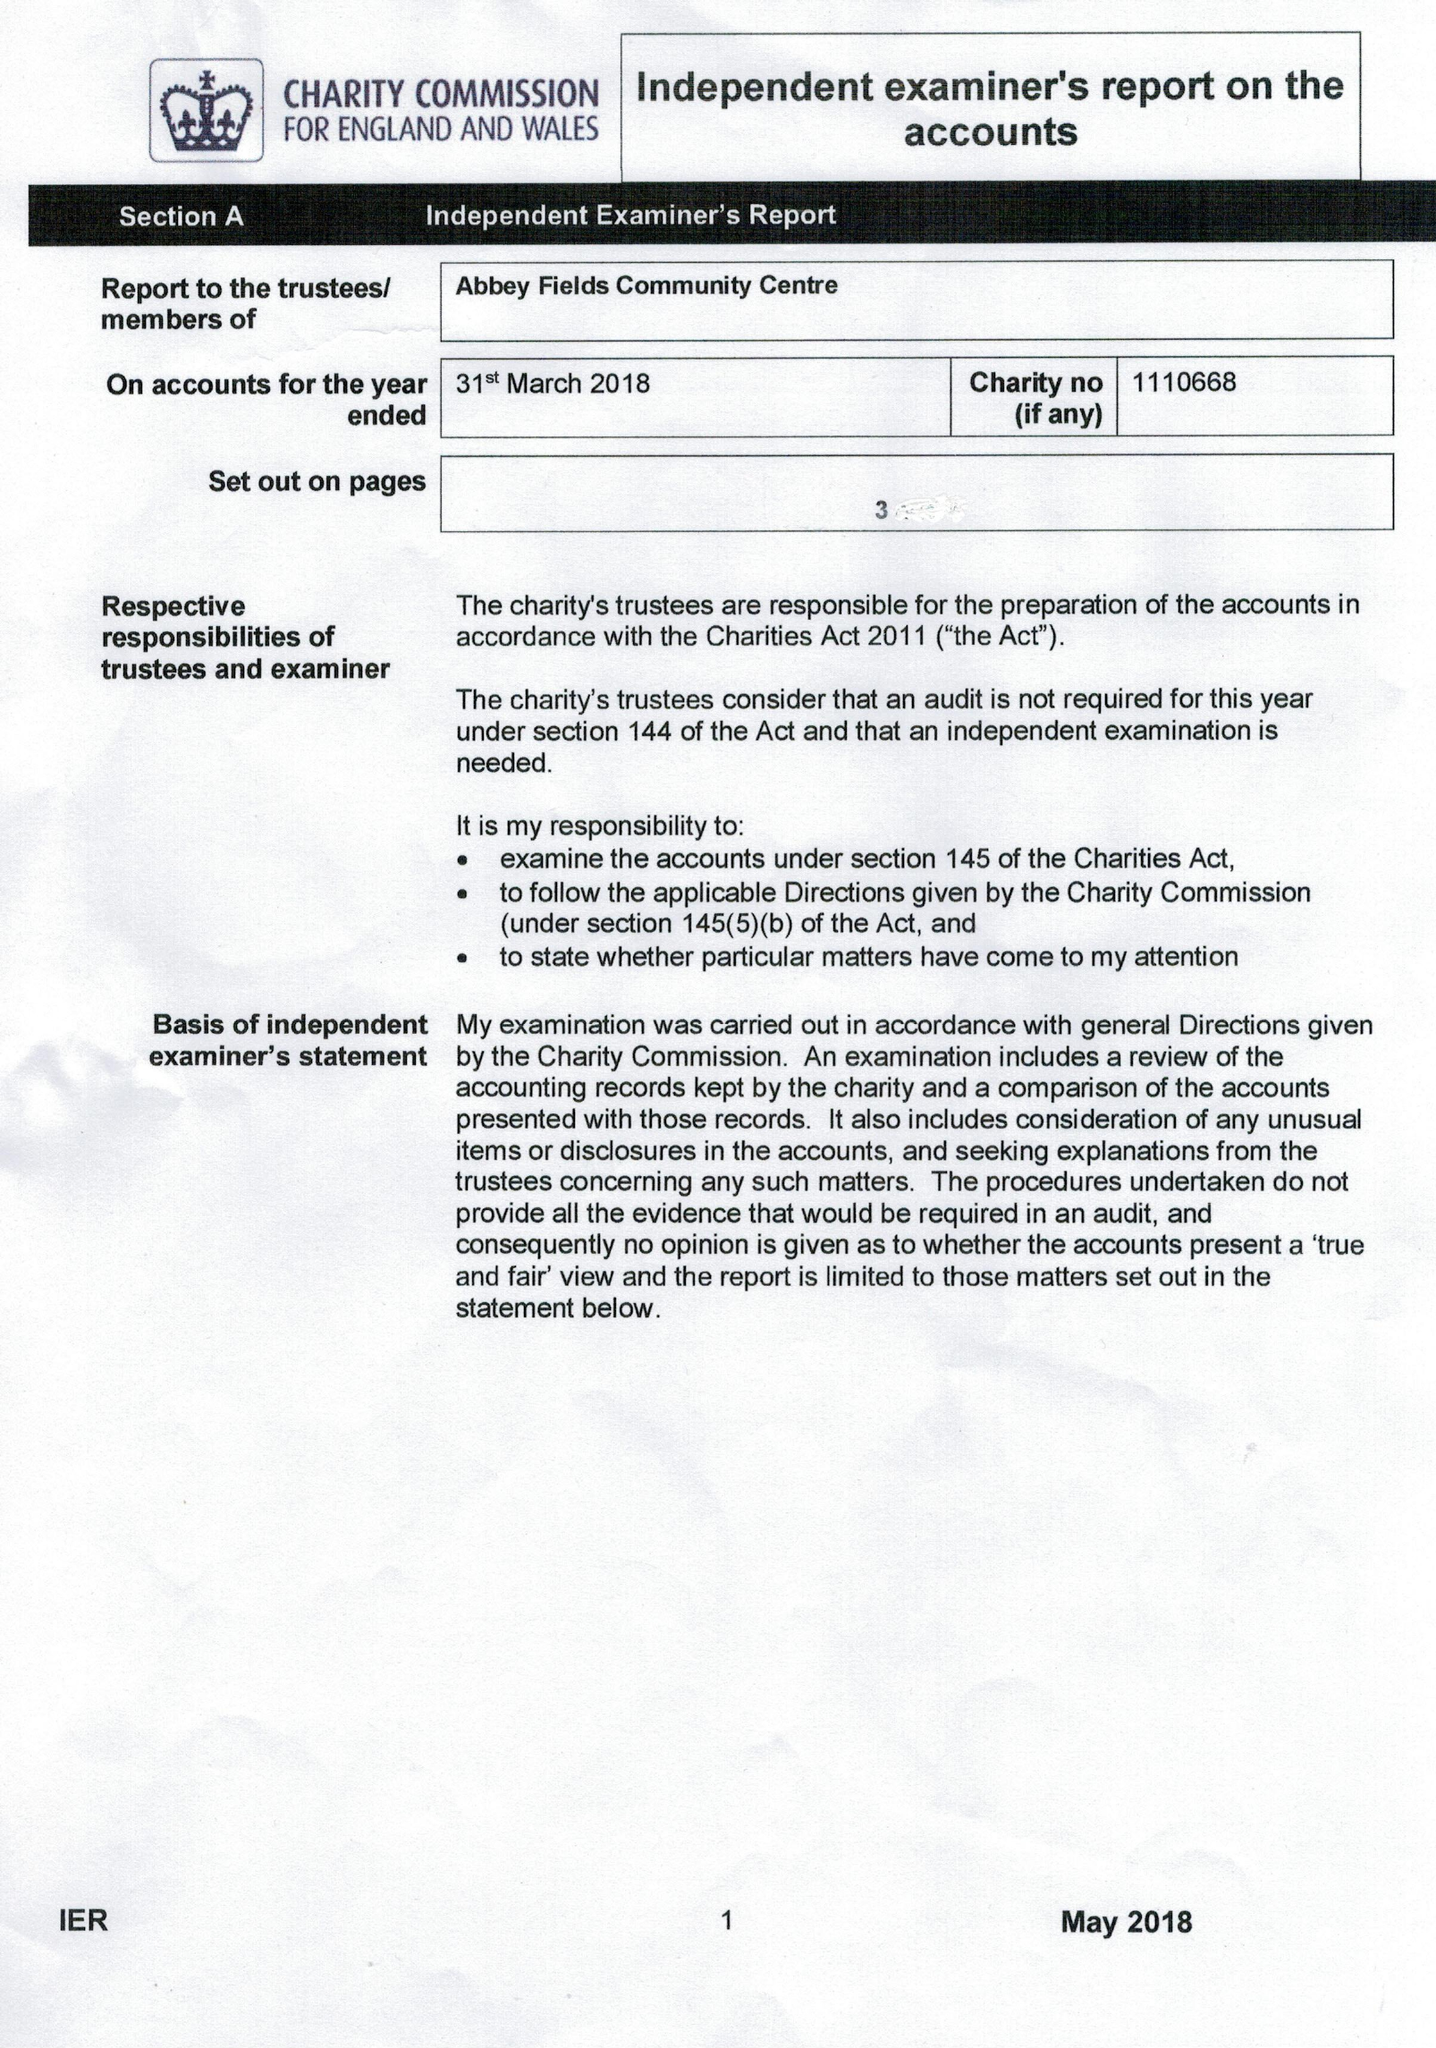What is the value for the report_date?
Answer the question using a single word or phrase. 2018-03-31 